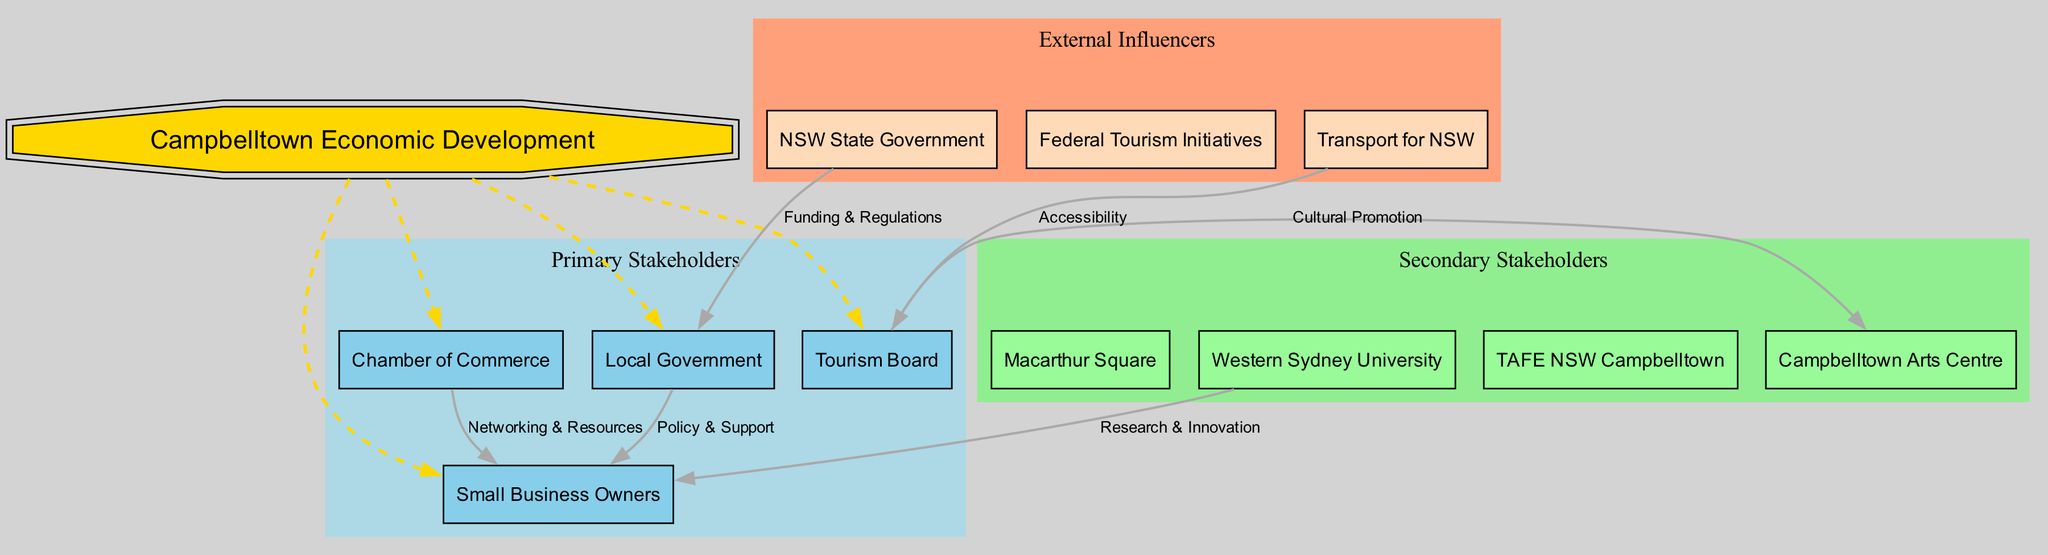What is the central node of the diagram? The central node is labeled "Campbelltown Economic Development." This is clearly indicated as the focal point of the diagram.
Answer: Campbelltown Economic Development How many primary stakeholders are there? The primary stakeholders listed are four: Local Government, Chamber of Commerce, Tourism Board, and Small Business Owners. This can be found in the section labeled "Primary Stakeholders."
Answer: 4 What type of connection exists between the Chamber of Commerce and Small Business Owners? The connection between the Chamber of Commerce and Small Business Owners is labeled "Networking & Resources." This label describes the nature of their relationship effectively.
Answer: Networking & Resources Who influences the Local Government? The Local Government is influenced by the NSW State Government, as indicated by the connection labeled "Funding & Regulations" leading from the state government to the local government.
Answer: NSW State Government How many connections are there in total? There are six connections in total, as indicated by the number of edges shown in the diagram among stakeholders. This includes all the established relationships listed.
Answer: 6 Which stakeholder is linked to the Campbelltown Arts Centre? The stakeholder connected to the Campbelltown Arts Centre is the Tourism Board, as indicated by the connection labeled "Cultural Promotion."
Answer: Tourism Board What do the arrows indicate in this diagram? The arrows indicate the direction of influence or relationship between the nodes. Each arrow points from one stakeholder to another, showing who provides support or resources to whom.
Answer: Direction of influence Which group is represented as secondary stakeholders? The secondary stakeholders are Macarthur Square, Western Sydney University, TAFE NSW Campbelltown, and Campbelltown Arts Centre. These are categorized under the "Secondary Stakeholders" section of the diagram.
Answer: Macarthur Square, Western Sydney University, TAFE NSW Campbelltown, Campbelltown Arts Centre What label describes the connection from Transport for NSW to the Tourism Board? The connection from Transport for NSW to the Tourism Board is labeled "Accessibility," indicating that Transport for NSW plays a role in making the area accessible for tourism.
Answer: Accessibility 